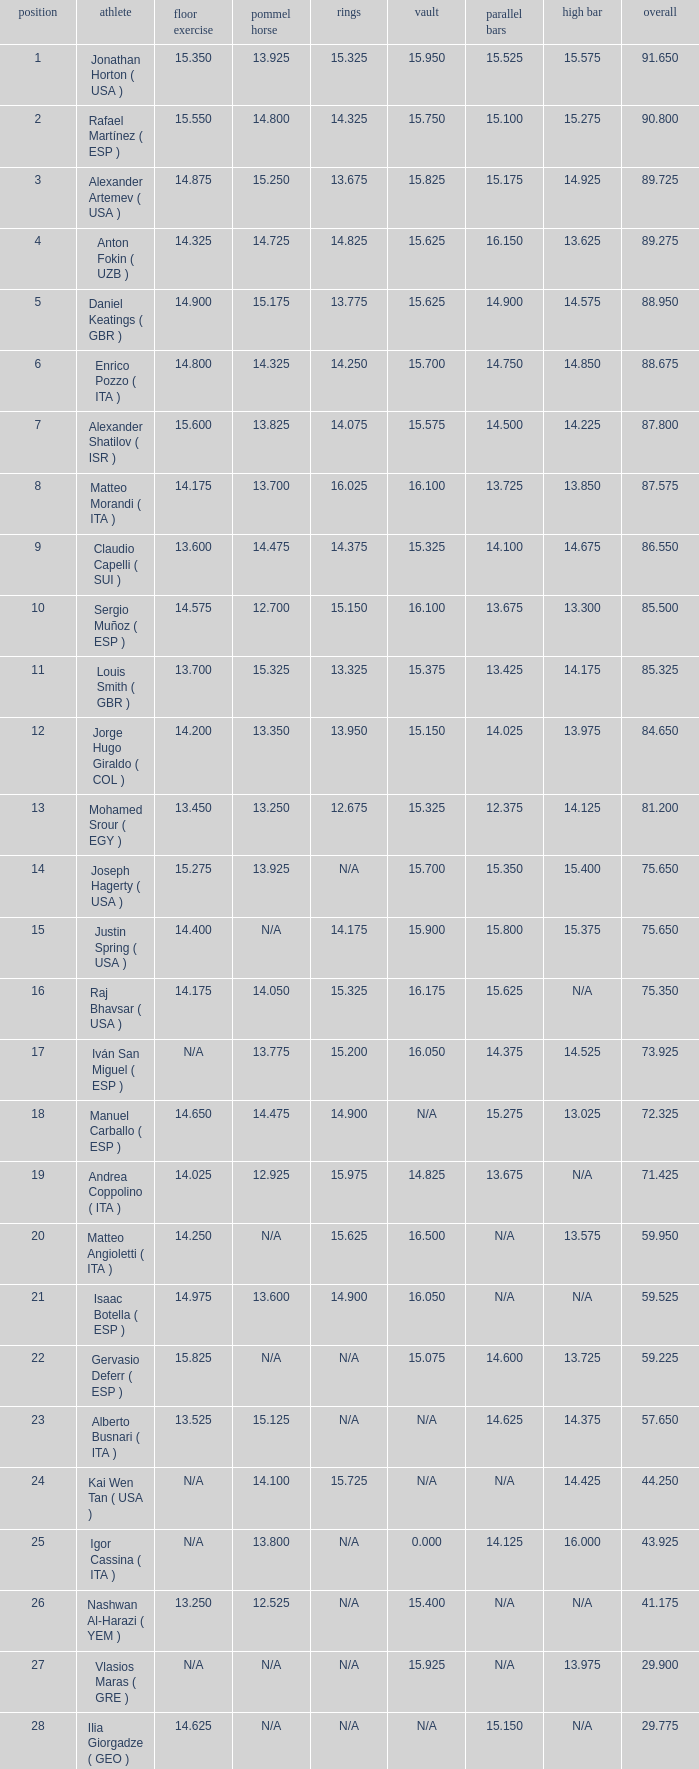If the parallel bars is 16.150, who is the gymnast? Anton Fokin ( UZB ). 